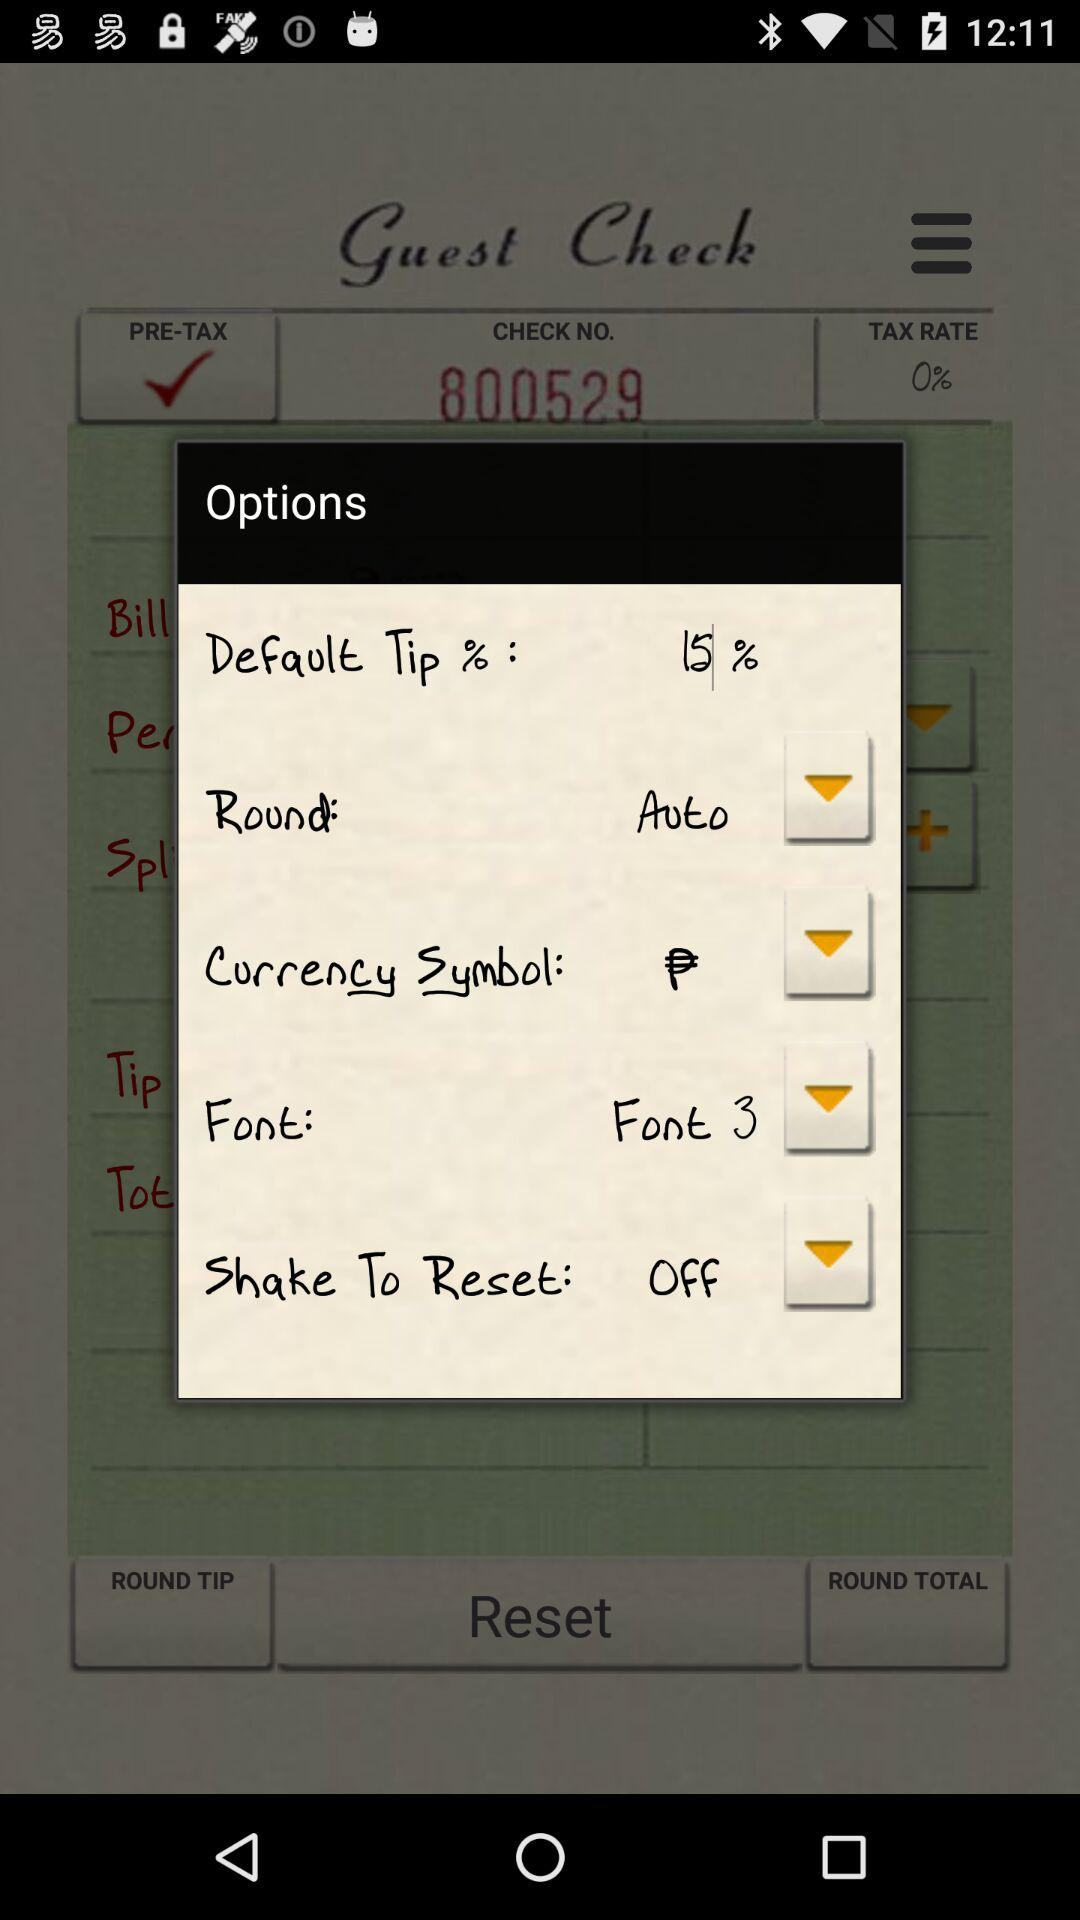What is the tax rate that applies? The tax rate is 0%. 